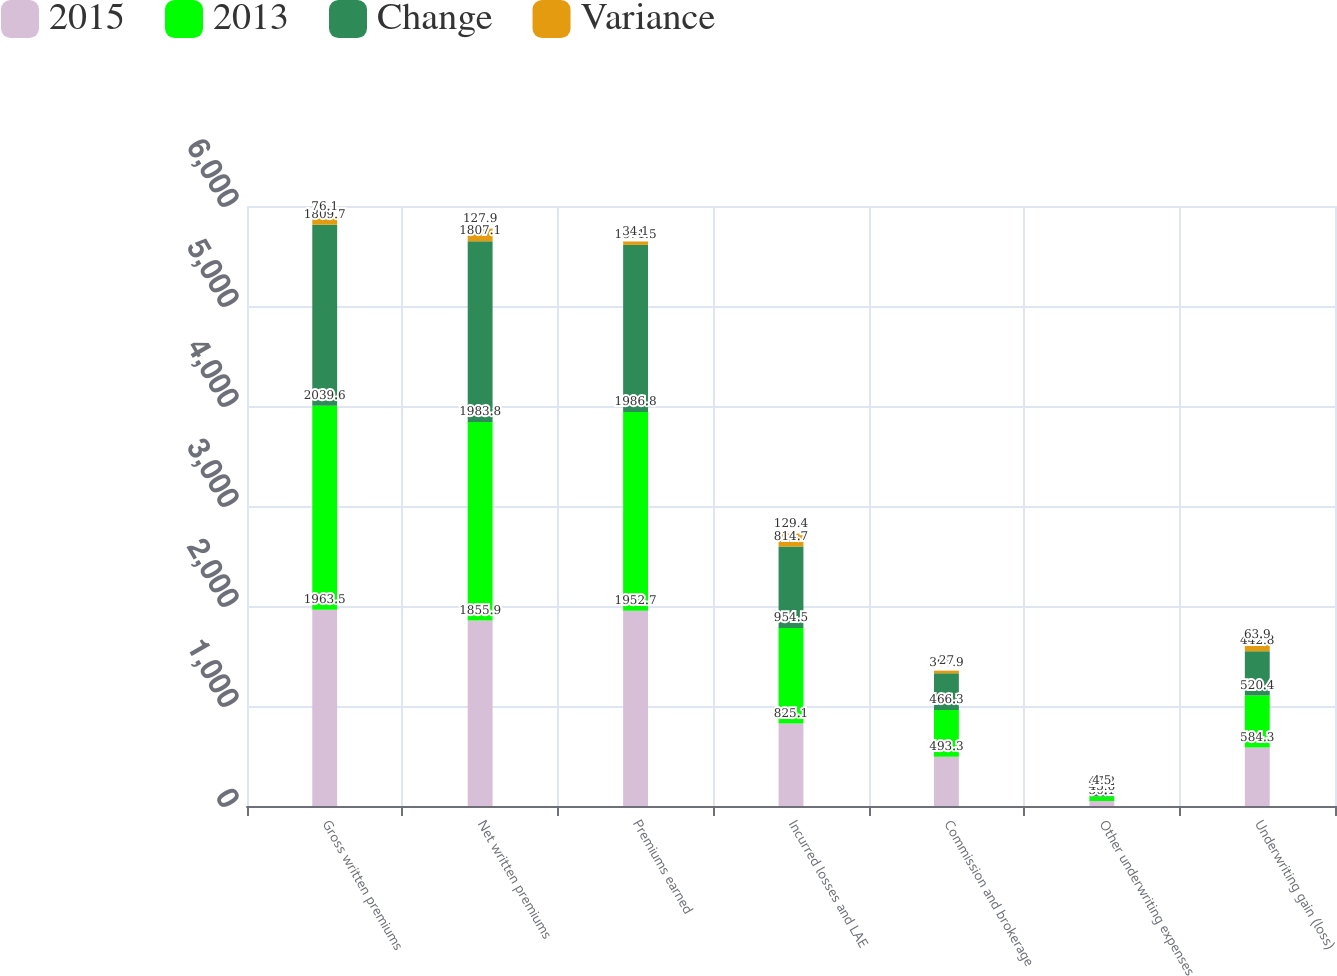Convert chart to OTSL. <chart><loc_0><loc_0><loc_500><loc_500><stacked_bar_chart><ecel><fcel>Gross written premiums<fcel>Net written premiums<fcel>Premiums earned<fcel>Incurred losses and LAE<fcel>Commission and brokerage<fcel>Other underwriting expenses<fcel>Underwriting gain (loss)<nl><fcel>2015<fcel>1963.5<fcel>1855.9<fcel>1952.7<fcel>825.1<fcel>493.3<fcel>50.1<fcel>584.3<nl><fcel>2013<fcel>2039.6<fcel>1983.8<fcel>1986.8<fcel>954.5<fcel>466.3<fcel>45.6<fcel>520.4<nl><fcel>Change<fcel>1809.7<fcel>1807.1<fcel>1671.5<fcel>814.7<fcel>366.9<fcel>47.2<fcel>442.8<nl><fcel>Variance<fcel>76.1<fcel>127.9<fcel>34.1<fcel>129.4<fcel>27<fcel>4.5<fcel>63.9<nl></chart> 